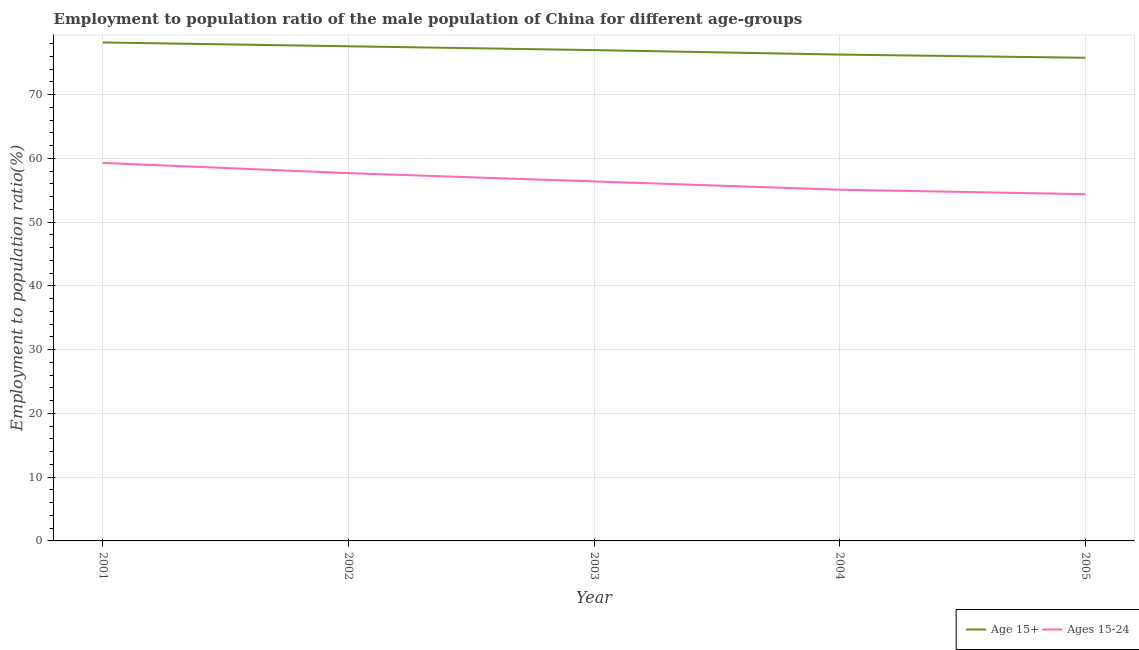Is the number of lines equal to the number of legend labels?
Keep it short and to the point. Yes. What is the employment to population ratio(age 15+) in 2001?
Offer a very short reply. 78.2. Across all years, what is the maximum employment to population ratio(age 15+)?
Your answer should be very brief. 78.2. Across all years, what is the minimum employment to population ratio(age 15+)?
Your answer should be compact. 75.8. In which year was the employment to population ratio(age 15-24) maximum?
Provide a short and direct response. 2001. What is the total employment to population ratio(age 15-24) in the graph?
Provide a short and direct response. 282.9. What is the difference between the employment to population ratio(age 15-24) in 2001 and that in 2003?
Offer a very short reply. 2.9. What is the difference between the employment to population ratio(age 15+) in 2005 and the employment to population ratio(age 15-24) in 2004?
Ensure brevity in your answer.  20.7. What is the average employment to population ratio(age 15+) per year?
Provide a succinct answer. 76.98. In the year 2001, what is the difference between the employment to population ratio(age 15+) and employment to population ratio(age 15-24)?
Make the answer very short. 18.9. What is the ratio of the employment to population ratio(age 15+) in 2003 to that in 2005?
Your response must be concise. 1.02. What is the difference between the highest and the second highest employment to population ratio(age 15-24)?
Make the answer very short. 1.6. What is the difference between the highest and the lowest employment to population ratio(age 15-24)?
Keep it short and to the point. 4.9. Is the sum of the employment to population ratio(age 15+) in 2001 and 2003 greater than the maximum employment to population ratio(age 15-24) across all years?
Your answer should be compact. Yes. Does the employment to population ratio(age 15+) monotonically increase over the years?
Provide a short and direct response. No. Is the employment to population ratio(age 15-24) strictly greater than the employment to population ratio(age 15+) over the years?
Give a very brief answer. No. How many years are there in the graph?
Your answer should be compact. 5. Does the graph contain any zero values?
Your answer should be compact. No. How are the legend labels stacked?
Keep it short and to the point. Horizontal. What is the title of the graph?
Provide a short and direct response. Employment to population ratio of the male population of China for different age-groups. Does "Canada" appear as one of the legend labels in the graph?
Your response must be concise. No. What is the label or title of the X-axis?
Offer a very short reply. Year. What is the label or title of the Y-axis?
Your answer should be compact. Employment to population ratio(%). What is the Employment to population ratio(%) of Age 15+ in 2001?
Your answer should be compact. 78.2. What is the Employment to population ratio(%) of Ages 15-24 in 2001?
Ensure brevity in your answer.  59.3. What is the Employment to population ratio(%) in Age 15+ in 2002?
Ensure brevity in your answer.  77.6. What is the Employment to population ratio(%) of Ages 15-24 in 2002?
Your answer should be compact. 57.7. What is the Employment to population ratio(%) of Ages 15-24 in 2003?
Offer a terse response. 56.4. What is the Employment to population ratio(%) in Age 15+ in 2004?
Ensure brevity in your answer.  76.3. What is the Employment to population ratio(%) of Ages 15-24 in 2004?
Provide a succinct answer. 55.1. What is the Employment to population ratio(%) of Age 15+ in 2005?
Ensure brevity in your answer.  75.8. What is the Employment to population ratio(%) of Ages 15-24 in 2005?
Offer a very short reply. 54.4. Across all years, what is the maximum Employment to population ratio(%) of Age 15+?
Make the answer very short. 78.2. Across all years, what is the maximum Employment to population ratio(%) in Ages 15-24?
Make the answer very short. 59.3. Across all years, what is the minimum Employment to population ratio(%) of Age 15+?
Make the answer very short. 75.8. Across all years, what is the minimum Employment to population ratio(%) of Ages 15-24?
Offer a very short reply. 54.4. What is the total Employment to population ratio(%) of Age 15+ in the graph?
Keep it short and to the point. 384.9. What is the total Employment to population ratio(%) in Ages 15-24 in the graph?
Give a very brief answer. 282.9. What is the difference between the Employment to population ratio(%) in Age 15+ in 2001 and that in 2002?
Your response must be concise. 0.6. What is the difference between the Employment to population ratio(%) of Age 15+ in 2001 and that in 2003?
Offer a very short reply. 1.2. What is the difference between the Employment to population ratio(%) of Age 15+ in 2001 and that in 2005?
Ensure brevity in your answer.  2.4. What is the difference between the Employment to population ratio(%) in Ages 15-24 in 2001 and that in 2005?
Make the answer very short. 4.9. What is the difference between the Employment to population ratio(%) in Ages 15-24 in 2002 and that in 2003?
Offer a terse response. 1.3. What is the difference between the Employment to population ratio(%) in Age 15+ in 2002 and that in 2004?
Offer a terse response. 1.3. What is the difference between the Employment to population ratio(%) of Ages 15-24 in 2002 and that in 2005?
Your answer should be compact. 3.3. What is the difference between the Employment to population ratio(%) of Ages 15-24 in 2003 and that in 2004?
Provide a succinct answer. 1.3. What is the difference between the Employment to population ratio(%) of Age 15+ in 2003 and that in 2005?
Provide a short and direct response. 1.2. What is the difference between the Employment to population ratio(%) of Age 15+ in 2004 and that in 2005?
Your answer should be very brief. 0.5. What is the difference between the Employment to population ratio(%) of Ages 15-24 in 2004 and that in 2005?
Ensure brevity in your answer.  0.7. What is the difference between the Employment to population ratio(%) in Age 15+ in 2001 and the Employment to population ratio(%) in Ages 15-24 in 2002?
Keep it short and to the point. 20.5. What is the difference between the Employment to population ratio(%) in Age 15+ in 2001 and the Employment to population ratio(%) in Ages 15-24 in 2003?
Make the answer very short. 21.8. What is the difference between the Employment to population ratio(%) of Age 15+ in 2001 and the Employment to population ratio(%) of Ages 15-24 in 2004?
Provide a short and direct response. 23.1. What is the difference between the Employment to population ratio(%) of Age 15+ in 2001 and the Employment to population ratio(%) of Ages 15-24 in 2005?
Offer a terse response. 23.8. What is the difference between the Employment to population ratio(%) in Age 15+ in 2002 and the Employment to population ratio(%) in Ages 15-24 in 2003?
Provide a succinct answer. 21.2. What is the difference between the Employment to population ratio(%) in Age 15+ in 2002 and the Employment to population ratio(%) in Ages 15-24 in 2004?
Provide a short and direct response. 22.5. What is the difference between the Employment to population ratio(%) in Age 15+ in 2002 and the Employment to population ratio(%) in Ages 15-24 in 2005?
Keep it short and to the point. 23.2. What is the difference between the Employment to population ratio(%) in Age 15+ in 2003 and the Employment to population ratio(%) in Ages 15-24 in 2004?
Offer a terse response. 21.9. What is the difference between the Employment to population ratio(%) of Age 15+ in 2003 and the Employment to population ratio(%) of Ages 15-24 in 2005?
Your answer should be compact. 22.6. What is the difference between the Employment to population ratio(%) in Age 15+ in 2004 and the Employment to population ratio(%) in Ages 15-24 in 2005?
Keep it short and to the point. 21.9. What is the average Employment to population ratio(%) in Age 15+ per year?
Make the answer very short. 76.98. What is the average Employment to population ratio(%) of Ages 15-24 per year?
Offer a terse response. 56.58. In the year 2001, what is the difference between the Employment to population ratio(%) of Age 15+ and Employment to population ratio(%) of Ages 15-24?
Your answer should be compact. 18.9. In the year 2002, what is the difference between the Employment to population ratio(%) of Age 15+ and Employment to population ratio(%) of Ages 15-24?
Ensure brevity in your answer.  19.9. In the year 2003, what is the difference between the Employment to population ratio(%) in Age 15+ and Employment to population ratio(%) in Ages 15-24?
Keep it short and to the point. 20.6. In the year 2004, what is the difference between the Employment to population ratio(%) of Age 15+ and Employment to population ratio(%) of Ages 15-24?
Provide a succinct answer. 21.2. In the year 2005, what is the difference between the Employment to population ratio(%) of Age 15+ and Employment to population ratio(%) of Ages 15-24?
Ensure brevity in your answer.  21.4. What is the ratio of the Employment to population ratio(%) in Age 15+ in 2001 to that in 2002?
Offer a terse response. 1.01. What is the ratio of the Employment to population ratio(%) of Ages 15-24 in 2001 to that in 2002?
Make the answer very short. 1.03. What is the ratio of the Employment to population ratio(%) in Age 15+ in 2001 to that in 2003?
Provide a short and direct response. 1.02. What is the ratio of the Employment to population ratio(%) of Ages 15-24 in 2001 to that in 2003?
Make the answer very short. 1.05. What is the ratio of the Employment to population ratio(%) in Age 15+ in 2001 to that in 2004?
Your answer should be compact. 1.02. What is the ratio of the Employment to population ratio(%) in Ages 15-24 in 2001 to that in 2004?
Your answer should be compact. 1.08. What is the ratio of the Employment to population ratio(%) of Age 15+ in 2001 to that in 2005?
Give a very brief answer. 1.03. What is the ratio of the Employment to population ratio(%) in Ages 15-24 in 2001 to that in 2005?
Keep it short and to the point. 1.09. What is the ratio of the Employment to population ratio(%) in Age 15+ in 2002 to that in 2003?
Offer a terse response. 1.01. What is the ratio of the Employment to population ratio(%) of Ages 15-24 in 2002 to that in 2004?
Your response must be concise. 1.05. What is the ratio of the Employment to population ratio(%) of Age 15+ in 2002 to that in 2005?
Provide a short and direct response. 1.02. What is the ratio of the Employment to population ratio(%) in Ages 15-24 in 2002 to that in 2005?
Ensure brevity in your answer.  1.06. What is the ratio of the Employment to population ratio(%) of Age 15+ in 2003 to that in 2004?
Your response must be concise. 1.01. What is the ratio of the Employment to population ratio(%) of Ages 15-24 in 2003 to that in 2004?
Your answer should be very brief. 1.02. What is the ratio of the Employment to population ratio(%) of Age 15+ in 2003 to that in 2005?
Your response must be concise. 1.02. What is the ratio of the Employment to population ratio(%) of Ages 15-24 in 2003 to that in 2005?
Ensure brevity in your answer.  1.04. What is the ratio of the Employment to population ratio(%) of Age 15+ in 2004 to that in 2005?
Keep it short and to the point. 1.01. What is the ratio of the Employment to population ratio(%) of Ages 15-24 in 2004 to that in 2005?
Give a very brief answer. 1.01. 